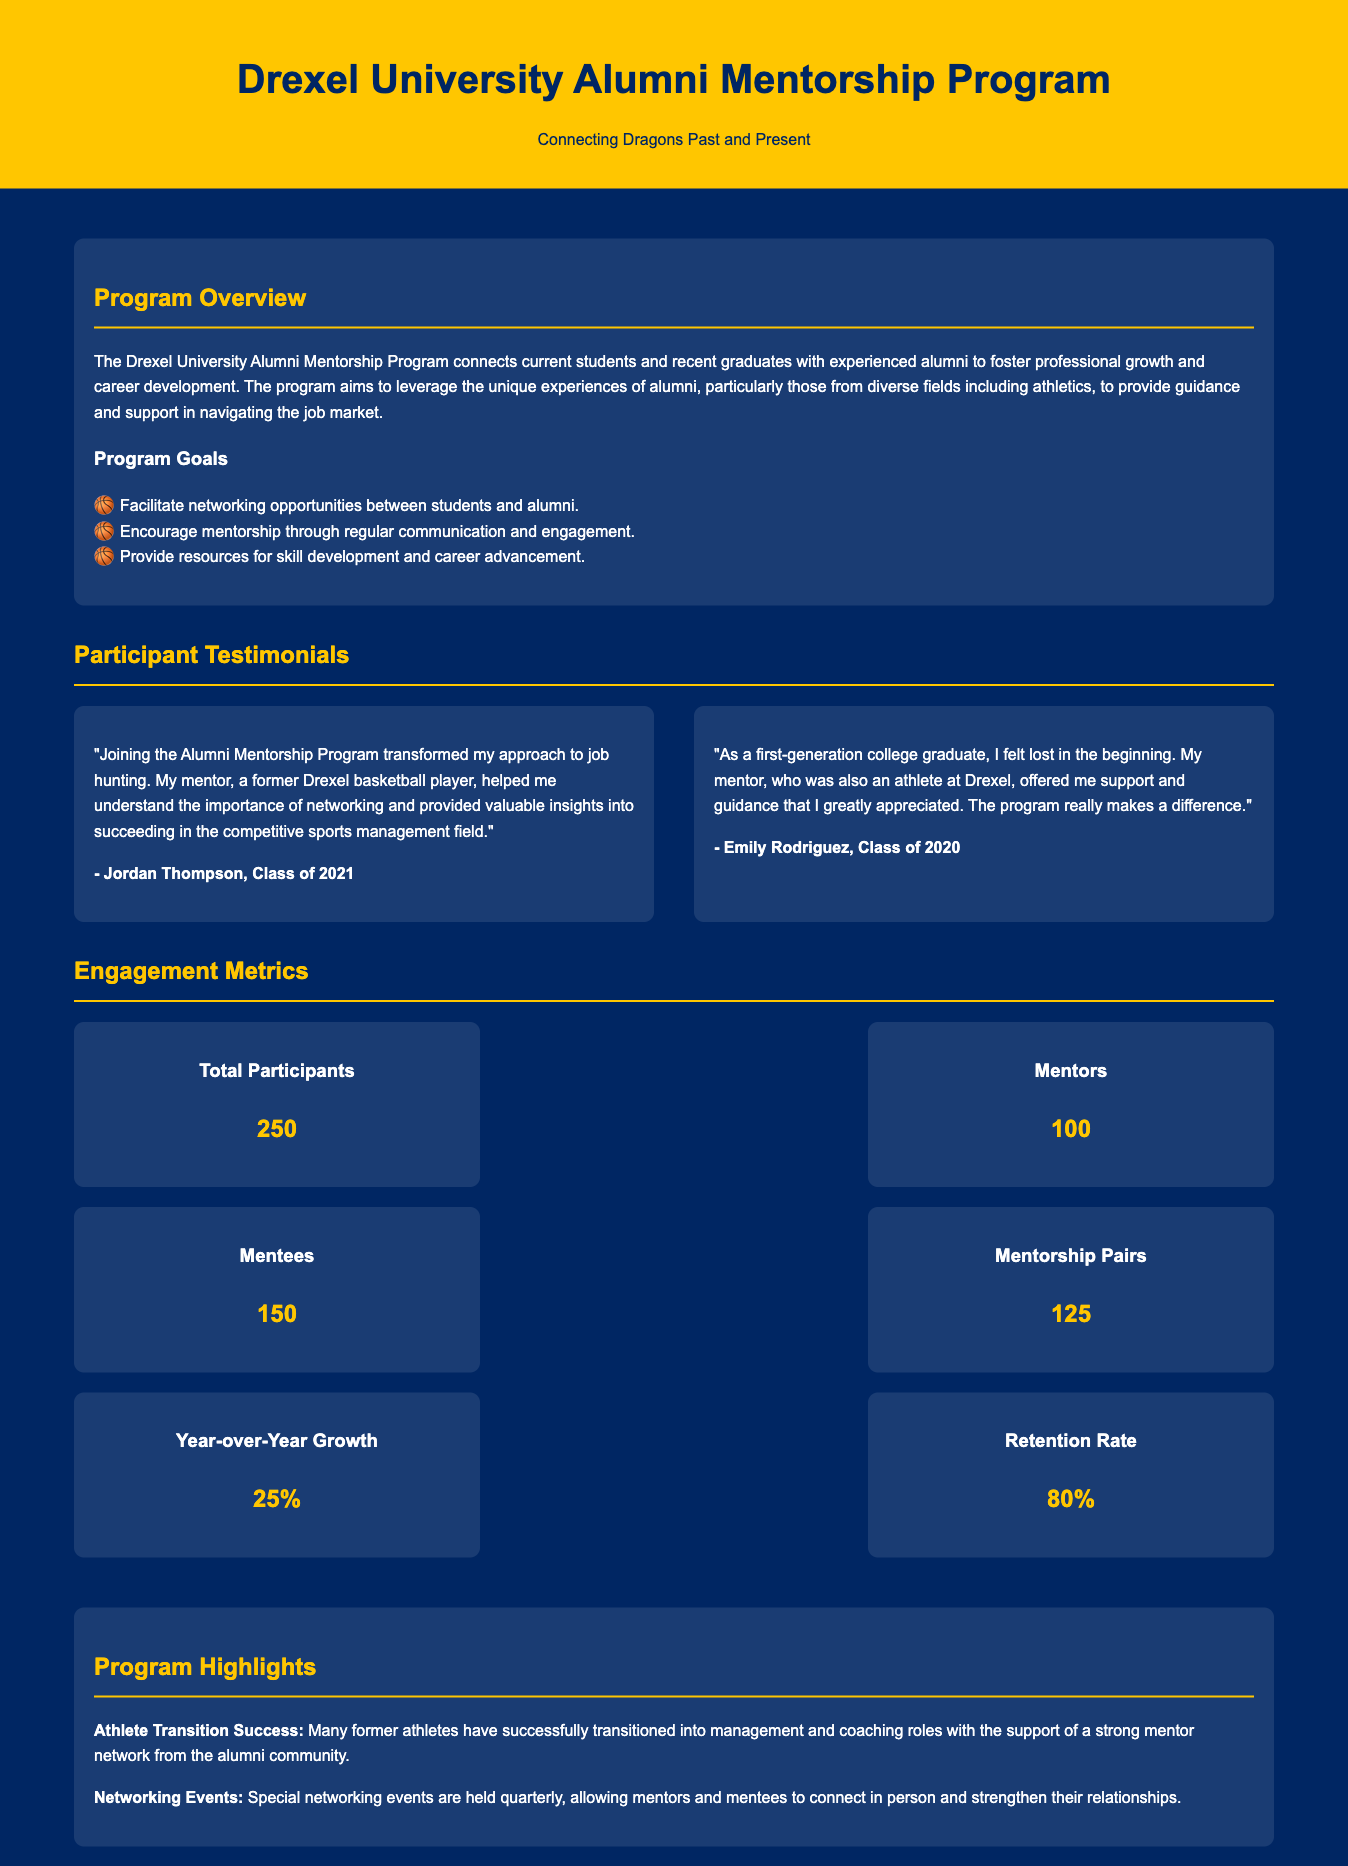what is the total number of participants? The document states that there are 250 total participants in the program.
Answer: 250 how many mentors are involved in the program? According to the document, there are 100 mentors participating.
Answer: 100 what is the retention rate of the program? The document specifies that the retention rate is 80%.
Answer: 80% who provided valuable insights into networking? Jordan Thompson mentioned that his mentor, a former Drexel basketball player, helped him understand networking.
Answer: a former Drexel basketball player what percentage represents the year-over-year growth? The document states the year-over-year growth is 25%.
Answer: 25% how many mentees are participating in the program? The document indicates that there are 150 mentees enrolled.
Answer: 150 what type of events are held quarterly? The document mentions special networking events are held quarterly.
Answer: networking events which cohort expressed feeling lost and appreciated mentorship support? Emily Rodriguez, Class of 2020, expressed feeling lost and appreciated her mentor's support.
Answer: Emily Rodriguez, Class of 2020 what is a significant highlight related to athlete transition? The document notes that many former athletes have successfully transitioned into management and coaching roles.
Answer: successful transition into management and coaching roles 